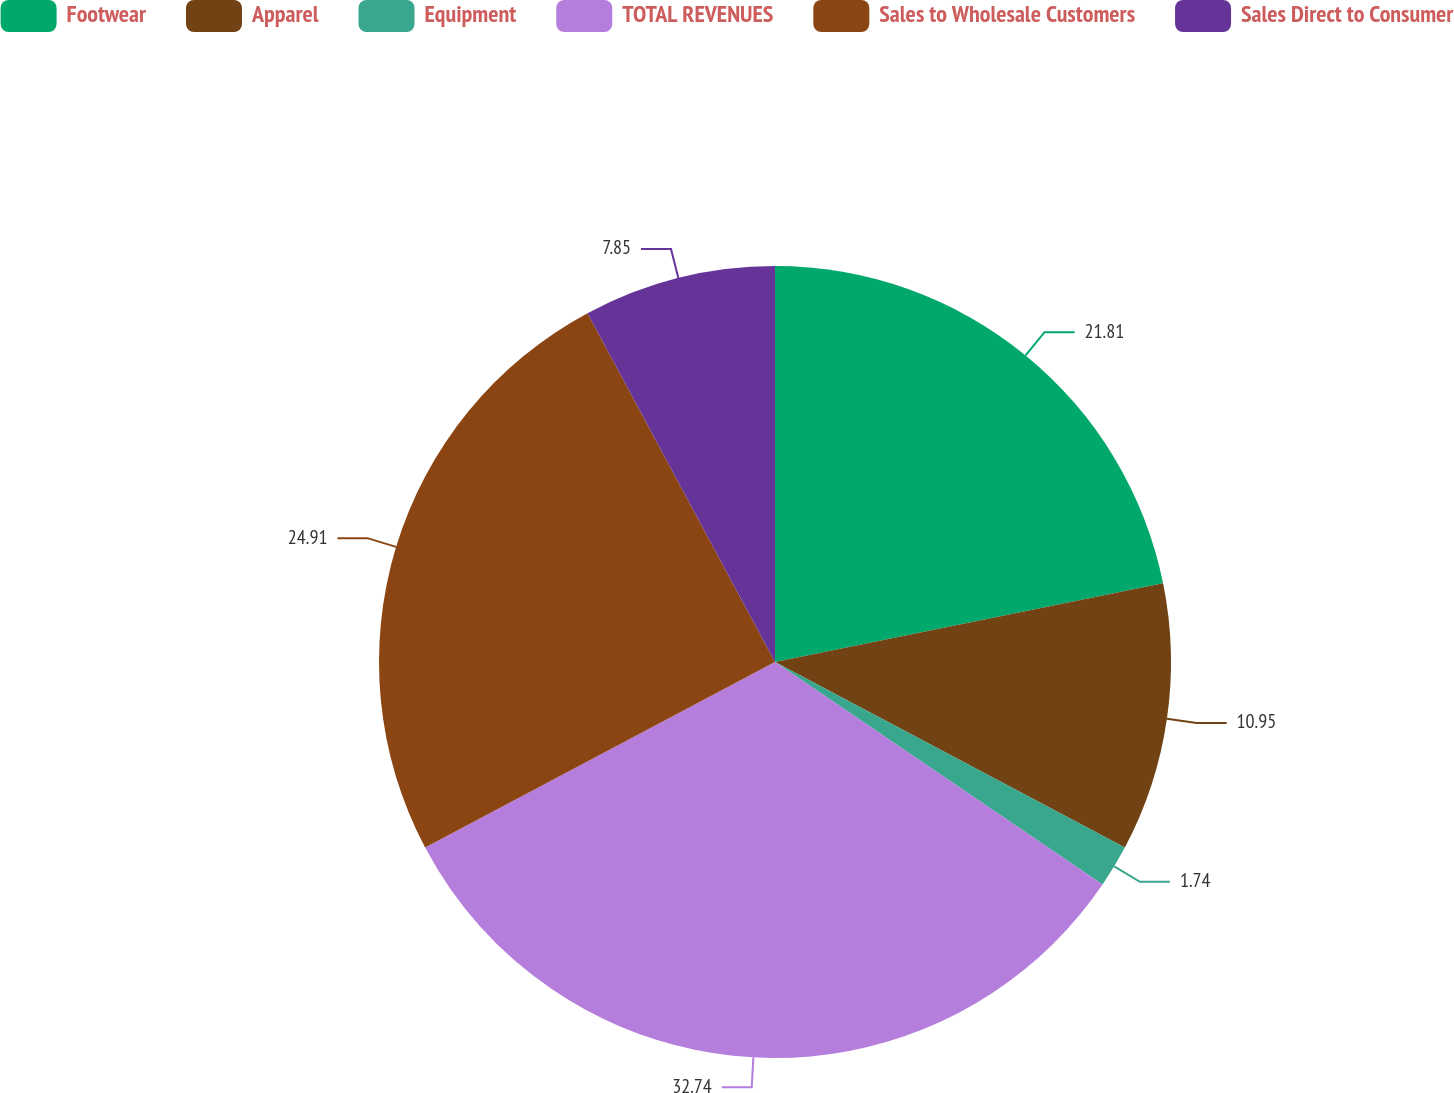Convert chart to OTSL. <chart><loc_0><loc_0><loc_500><loc_500><pie_chart><fcel>Footwear<fcel>Apparel<fcel>Equipment<fcel>TOTAL REVENUES<fcel>Sales to Wholesale Customers<fcel>Sales Direct to Consumer<nl><fcel>21.81%<fcel>10.95%<fcel>1.74%<fcel>32.74%<fcel>24.91%<fcel>7.85%<nl></chart> 